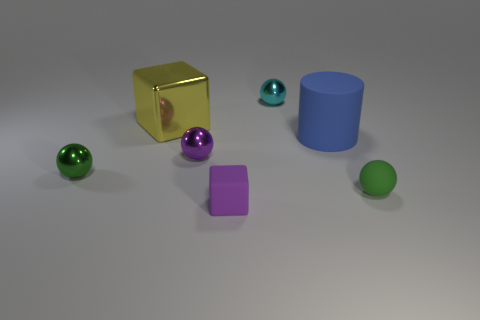Subtract all small cyan metallic spheres. How many spheres are left? 3 Add 1 blue objects. How many objects exist? 8 Subtract all purple blocks. How many blocks are left? 1 Subtract 1 blue cylinders. How many objects are left? 6 Subtract all blocks. How many objects are left? 5 Subtract 1 cubes. How many cubes are left? 1 Subtract all gray cubes. Subtract all purple balls. How many cubes are left? 2 Subtract all yellow spheres. How many purple cylinders are left? 0 Subtract all blue objects. Subtract all tiny shiny objects. How many objects are left? 3 Add 6 cyan metal objects. How many cyan metal objects are left? 7 